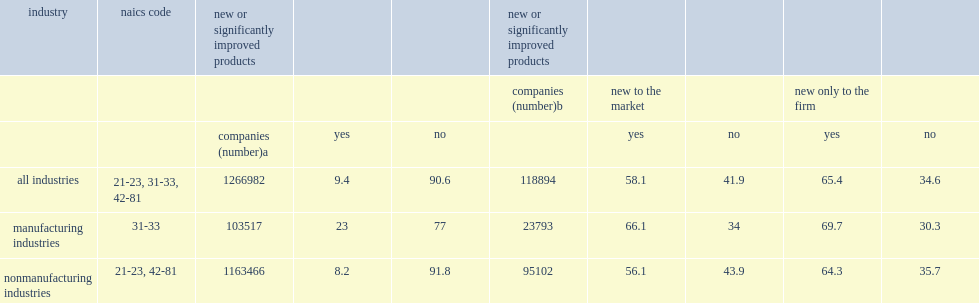Of those companies, how many percent introduced product innovations that are new to the company's market? 58.1. Of those companies, how many percent introduced product innovations that are new only to the firm? 65.4. In the manufacturing sector, how many percent of companies reported product innovations? 23.0. In the manufacturing sector, how many percent of those companies said their products were new to the market? 66.1. In the manufacturing sector, how many percent reported product innovations as new only to the firm? 69.7. In the nonmanufacturing sector, how many percent of companies reported product innovations? 8.2. In the nonmanufacturing sector, how many percent for new to the market? 56.1. In the nonmanufacturing sector, how many percent for new only to the firm? 64.3. 